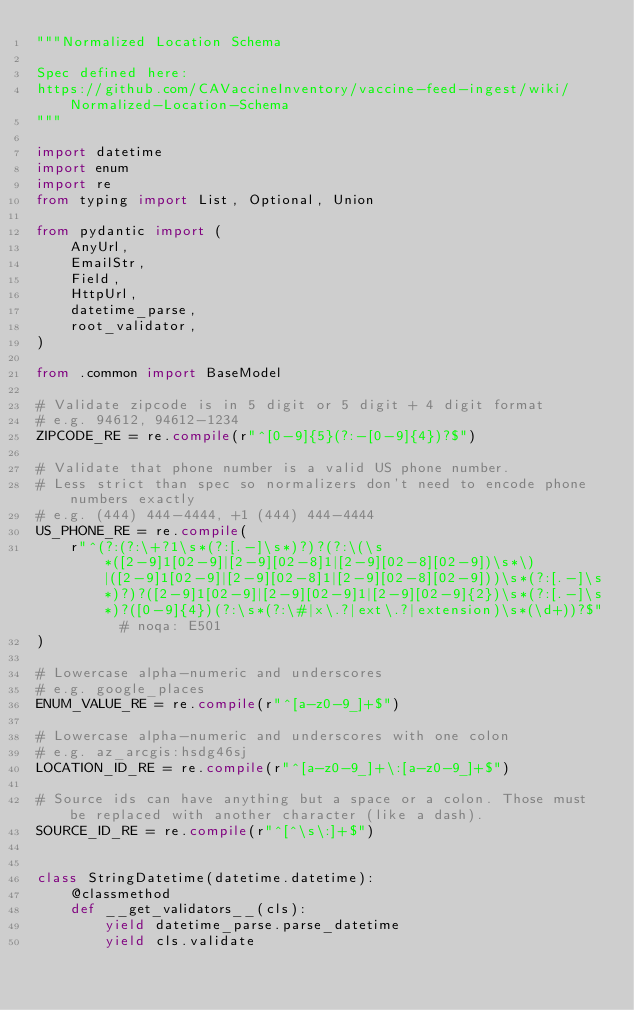Convert code to text. <code><loc_0><loc_0><loc_500><loc_500><_Python_>"""Normalized Location Schema

Spec defined here:
https://github.com/CAVaccineInventory/vaccine-feed-ingest/wiki/Normalized-Location-Schema
"""

import datetime
import enum
import re
from typing import List, Optional, Union

from pydantic import (
    AnyUrl,
    EmailStr,
    Field,
    HttpUrl,
    datetime_parse,
    root_validator,
)

from .common import BaseModel

# Validate zipcode is in 5 digit or 5 digit + 4 digit format
# e.g. 94612, 94612-1234
ZIPCODE_RE = re.compile(r"^[0-9]{5}(?:-[0-9]{4})?$")

# Validate that phone number is a valid US phone number.
# Less strict than spec so normalizers don't need to encode phone numbers exactly
# e.g. (444) 444-4444, +1 (444) 444-4444
US_PHONE_RE = re.compile(
    r"^(?:(?:\+?1\s*(?:[.-]\s*)?)?(?:\(\s*([2-9]1[02-9]|[2-9][02-8]1|[2-9][02-8][02-9])\s*\)|([2-9]1[02-9]|[2-9][02-8]1|[2-9][02-8][02-9]))\s*(?:[.-]\s*)?)?([2-9]1[02-9]|[2-9][02-9]1|[2-9][02-9]{2})\s*(?:[.-]\s*)?([0-9]{4})(?:\s*(?:\#|x\.?|ext\.?|extension)\s*(\d+))?$"  # noqa: E501
)

# Lowercase alpha-numeric and underscores
# e.g. google_places
ENUM_VALUE_RE = re.compile(r"^[a-z0-9_]+$")

# Lowercase alpha-numeric and underscores with one colon
# e.g. az_arcgis:hsdg46sj
LOCATION_ID_RE = re.compile(r"^[a-z0-9_]+\:[a-z0-9_]+$")

# Source ids can have anything but a space or a colon. Those must be replaced with another character (like a dash).
SOURCE_ID_RE = re.compile(r"^[^\s\:]+$")


class StringDatetime(datetime.datetime):
    @classmethod
    def __get_validators__(cls):
        yield datetime_parse.parse_datetime
        yield cls.validate
</code> 